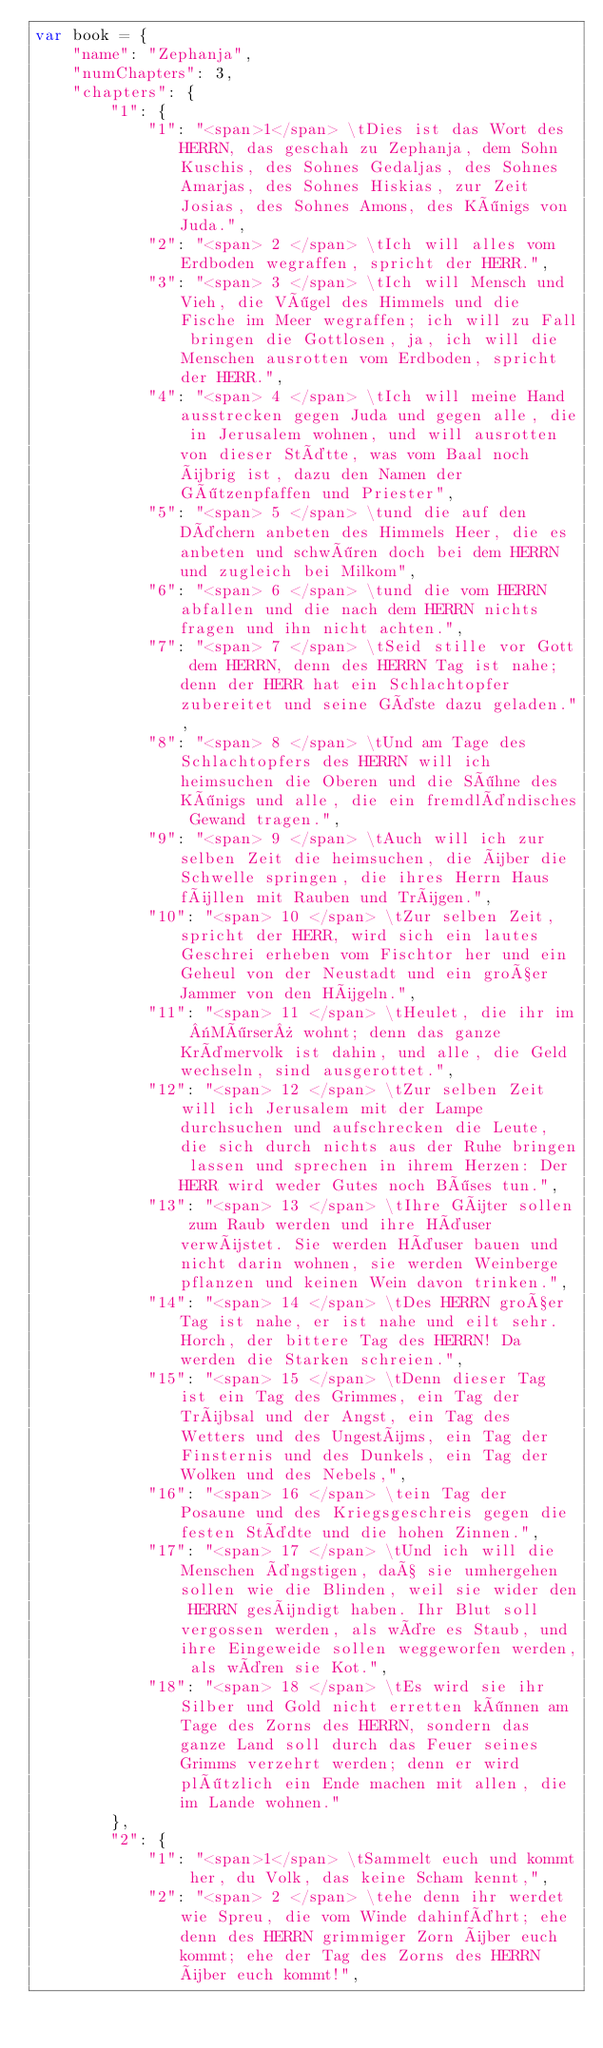<code> <loc_0><loc_0><loc_500><loc_500><_JavaScript_>var book = {
	"name": "Zephanja",
	"numChapters": 3,
	"chapters": {
		"1": {
			"1": "<span>1</span> \tDies ist das Wort des HERRN, das geschah zu Zephanja, dem Sohn Kuschis, des Sohnes Gedaljas, des Sohnes Amarjas, des Sohnes Hiskias, zur Zeit Josias, des Sohnes Amons, des Königs von Juda.",
			"2": "<span> 2 </span> \tIch will alles vom Erdboden wegraffen, spricht der HERR.",
			"3": "<span> 3 </span> \tIch will Mensch und Vieh, die Vögel des Himmels und die Fische im Meer wegraffen; ich will zu Fall bringen die Gottlosen, ja, ich will die Menschen ausrotten vom Erdboden, spricht der HERR.",
			"4": "<span> 4 </span> \tIch will meine Hand ausstrecken gegen Juda und gegen alle, die in Jerusalem wohnen, und will ausrotten von dieser Stätte, was vom Baal noch übrig ist, dazu den Namen der Götzenpfaffen und Priester",
			"5": "<span> 5 </span> \tund die auf den Dächern anbeten des Himmels Heer, die es anbeten und schwören doch bei dem HERRN und zugleich bei Milkom",
			"6": "<span> 6 </span> \tund die vom HERRN abfallen und die nach dem HERRN nichts fragen und ihn nicht achten.",
			"7": "<span> 7 </span> \tSeid stille vor Gott dem HERRN, denn des HERRN Tag ist nahe; denn der HERR hat ein Schlachtopfer zubereitet und seine Gäste dazu geladen.",
			"8": "<span> 8 </span> \tUnd am Tage des Schlachtopfers des HERRN will ich heimsuchen die Oberen und die Söhne des Königs und alle, die ein fremdländisches Gewand tragen.",
			"9": "<span> 9 </span> \tAuch will ich zur selben Zeit die heimsuchen, die über die Schwelle springen, die ihres Herrn Haus füllen mit Rauben und Trügen.",
			"10": "<span> 10 </span> \tZur selben Zeit, spricht der HERR, wird sich ein lautes Geschrei erheben vom Fischtor her und ein Geheul von der Neustadt und ein großer Jammer von den Hügeln.",
			"11": "<span> 11 </span> \tHeulet, die ihr im «Mörser» wohnt; denn das ganze Krämervolk ist dahin, und alle, die Geld wechseln, sind ausgerottet.",
			"12": "<span> 12 </span> \tZur selben Zeit will ich Jerusalem mit der Lampe durchsuchen und aufschrecken die Leute, die sich durch nichts aus der Ruhe bringen lassen und sprechen in ihrem Herzen: Der HERR wird weder Gutes noch Böses tun.",
			"13": "<span> 13 </span> \tIhre Güter sollen zum Raub werden und ihre Häuser verwüstet. Sie werden Häuser bauen und nicht darin wohnen, sie werden Weinberge pflanzen und keinen Wein davon trinken.",
			"14": "<span> 14 </span> \tDes HERRN großer Tag ist nahe, er ist nahe und eilt sehr. Horch, der bittere Tag des HERRN! Da werden die Starken schreien.",
			"15": "<span> 15 </span> \tDenn dieser Tag ist ein Tag des Grimmes, ein Tag der Trübsal und der Angst, ein Tag des Wetters und des Ungestüms, ein Tag der Finsternis und des Dunkels, ein Tag der Wolken und des Nebels,",
			"16": "<span> 16 </span> \tein Tag der Posaune und des Kriegsgeschreis gegen die festen Städte und die hohen Zinnen.",
			"17": "<span> 17 </span> \tUnd ich will die Menschen ängstigen, daß sie umhergehen sollen wie die Blinden, weil sie wider den HERRN gesündigt haben. Ihr Blut soll vergossen werden, als wäre es Staub, und ihre Eingeweide sollen weggeworfen werden, als wären sie Kot.",
			"18": "<span> 18 </span> \tEs wird sie ihr Silber und Gold nicht erretten können am Tage des Zorns des HERRN, sondern das ganze Land soll durch das Feuer seines Grimms verzehrt werden; denn er wird plötzlich ein Ende machen mit allen, die im Lande wohnen."
		},
		"2": {
			"1": "<span>1</span> \tSammelt euch und kommt her, du Volk, das keine Scham kennt,",
			"2": "<span> 2 </span> \tehe denn ihr werdet wie Spreu, die vom Winde dahinfährt; ehe denn des HERRN grimmiger Zorn über euch kommt; ehe der Tag des Zorns des HERRN über euch kommt!",</code> 